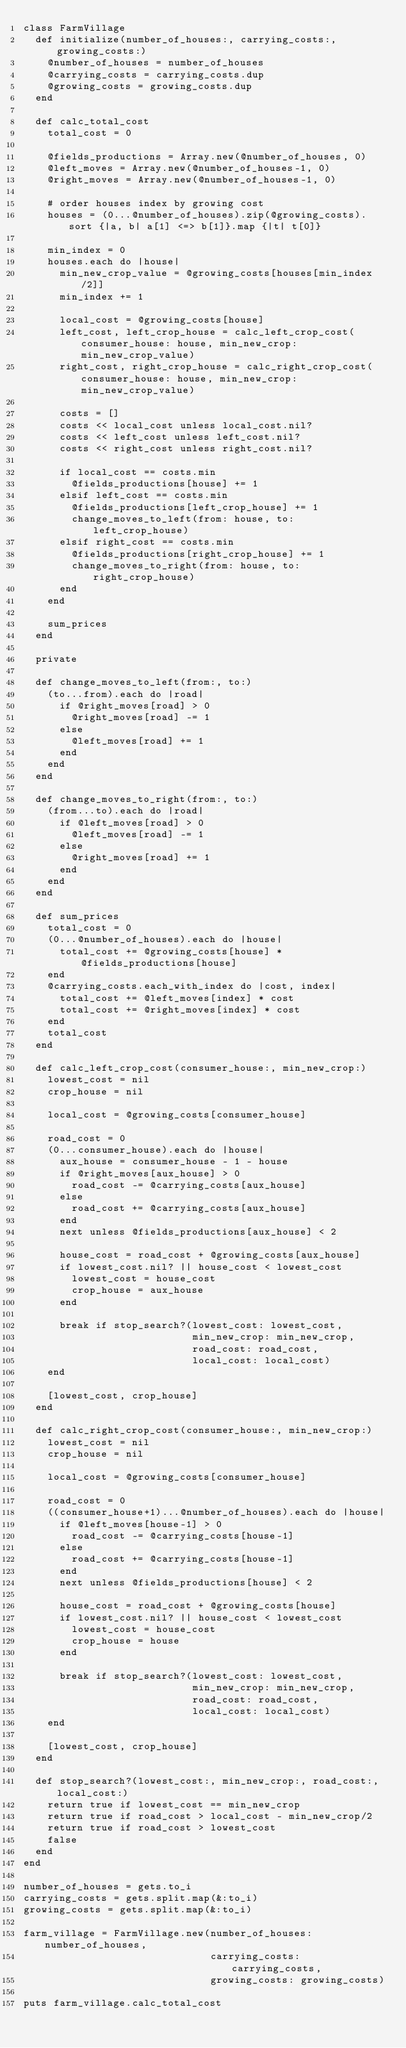Convert code to text. <code><loc_0><loc_0><loc_500><loc_500><_Ruby_>class FarmVillage
  def initialize(number_of_houses:, carrying_costs:, growing_costs:)
    @number_of_houses = number_of_houses
    @carrying_costs = carrying_costs.dup
    @growing_costs = growing_costs.dup
  end

  def calc_total_cost
    total_cost = 0

    @fields_productions = Array.new(@number_of_houses, 0)
    @left_moves = Array.new(@number_of_houses-1, 0)
    @right_moves = Array.new(@number_of_houses-1, 0)

    # order houses index by growing cost
    houses = (0...@number_of_houses).zip(@growing_costs).sort {|a, b| a[1] <=> b[1]}.map {|t| t[0]}

    min_index = 0
    houses.each do |house|
      min_new_crop_value = @growing_costs[houses[min_index/2]]
      min_index += 1

      local_cost = @growing_costs[house]
      left_cost, left_crop_house = calc_left_crop_cost(consumer_house: house, min_new_crop: min_new_crop_value)
      right_cost, right_crop_house = calc_right_crop_cost(consumer_house: house, min_new_crop: min_new_crop_value)

      costs = []
      costs << local_cost unless local_cost.nil?
      costs << left_cost unless left_cost.nil?
      costs << right_cost unless right_cost.nil?

      if local_cost == costs.min
        @fields_productions[house] += 1
      elsif left_cost == costs.min
        @fields_productions[left_crop_house] += 1
        change_moves_to_left(from: house, to: left_crop_house)
      elsif right_cost == costs.min
        @fields_productions[right_crop_house] += 1
        change_moves_to_right(from: house, to: right_crop_house)
      end
    end

    sum_prices
  end

  private

  def change_moves_to_left(from:, to:)
    (to...from).each do |road|
      if @right_moves[road] > 0
        @right_moves[road] -= 1
      else
        @left_moves[road] += 1
      end
    end
  end

  def change_moves_to_right(from:, to:)
    (from...to).each do |road|
      if @left_moves[road] > 0
        @left_moves[road] -= 1
      else
        @right_moves[road] += 1
      end
    end
  end

  def sum_prices
    total_cost = 0
    (0...@number_of_houses).each do |house|
      total_cost += @growing_costs[house] * @fields_productions[house]
    end
    @carrying_costs.each_with_index do |cost, index|
      total_cost += @left_moves[index] * cost
      total_cost += @right_moves[index] * cost
    end
    total_cost
  end

  def calc_left_crop_cost(consumer_house:, min_new_crop:)
    lowest_cost = nil
    crop_house = nil

    local_cost = @growing_costs[consumer_house]

    road_cost = 0
    (0...consumer_house).each do |house|
      aux_house = consumer_house - 1 - house
      if @right_moves[aux_house] > 0
        road_cost -= @carrying_costs[aux_house]
      else
        road_cost += @carrying_costs[aux_house]
      end
      next unless @fields_productions[aux_house] < 2

      house_cost = road_cost + @growing_costs[aux_house]
      if lowest_cost.nil? || house_cost < lowest_cost
        lowest_cost = house_cost
        crop_house = aux_house
      end

      break if stop_search?(lowest_cost: lowest_cost,
                            min_new_crop: min_new_crop,
                            road_cost: road_cost,
                            local_cost: local_cost)
    end

    [lowest_cost, crop_house]
  end

  def calc_right_crop_cost(consumer_house:, min_new_crop:)
    lowest_cost = nil
    crop_house = nil

    local_cost = @growing_costs[consumer_house]

    road_cost = 0
    ((consumer_house+1)...@number_of_houses).each do |house|
      if @left_moves[house-1] > 0
        road_cost -= @carrying_costs[house-1]
      else
        road_cost += @carrying_costs[house-1]
      end
      next unless @fields_productions[house] < 2

      house_cost = road_cost + @growing_costs[house]
      if lowest_cost.nil? || house_cost < lowest_cost
        lowest_cost = house_cost
        crop_house = house
      end

      break if stop_search?(lowest_cost: lowest_cost,
                            min_new_crop: min_new_crop,
                            road_cost: road_cost,
                            local_cost: local_cost)
    end

    [lowest_cost, crop_house]
  end

  def stop_search?(lowest_cost:, min_new_crop:, road_cost:, local_cost:)
    return true if lowest_cost == min_new_crop
    return true if road_cost > local_cost - min_new_crop/2
    return true if road_cost > lowest_cost
    false
  end
end

number_of_houses = gets.to_i
carrying_costs = gets.split.map(&:to_i)
growing_costs = gets.split.map(&:to_i)

farm_village = FarmVillage.new(number_of_houses: number_of_houses,
                               carrying_costs: carrying_costs,
                               growing_costs: growing_costs)

puts farm_village.calc_total_cost</code> 